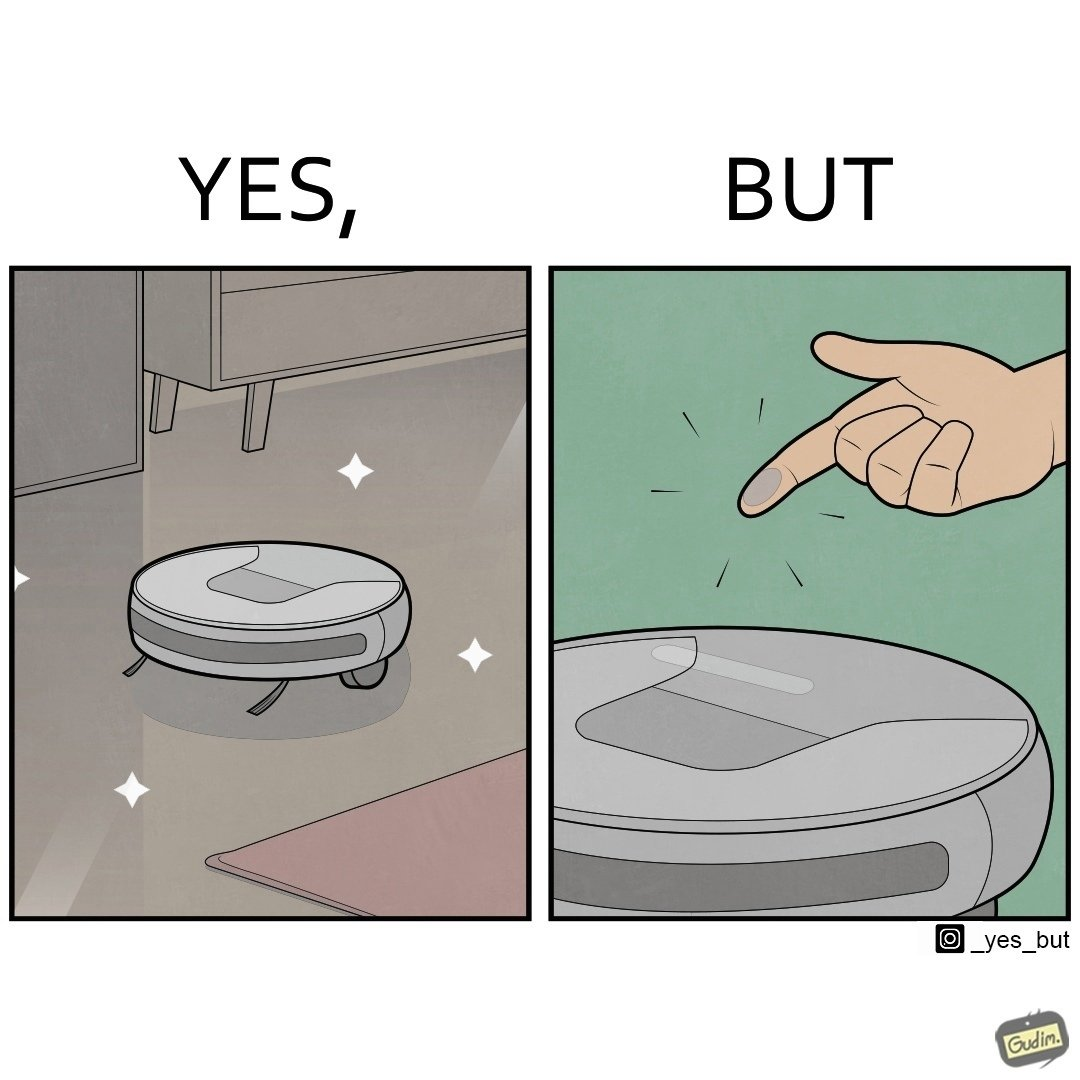Describe the contrast between the left and right parts of this image. In the left part of the image: A vacuum cleaning machine that goes around the floor on its own and cleans the floor. Everything  around it looks squeaky clean, and is shining. In the right part of the image: Close up of a vacuum cleaning machine that goes around the floor on its own and cleans the floor. Everything  around it looks squeaky clean, and is shining, but it has a lot of dust on it except one line on it that looks clean. A persons fingertip is visible, and it is covered in dust. 